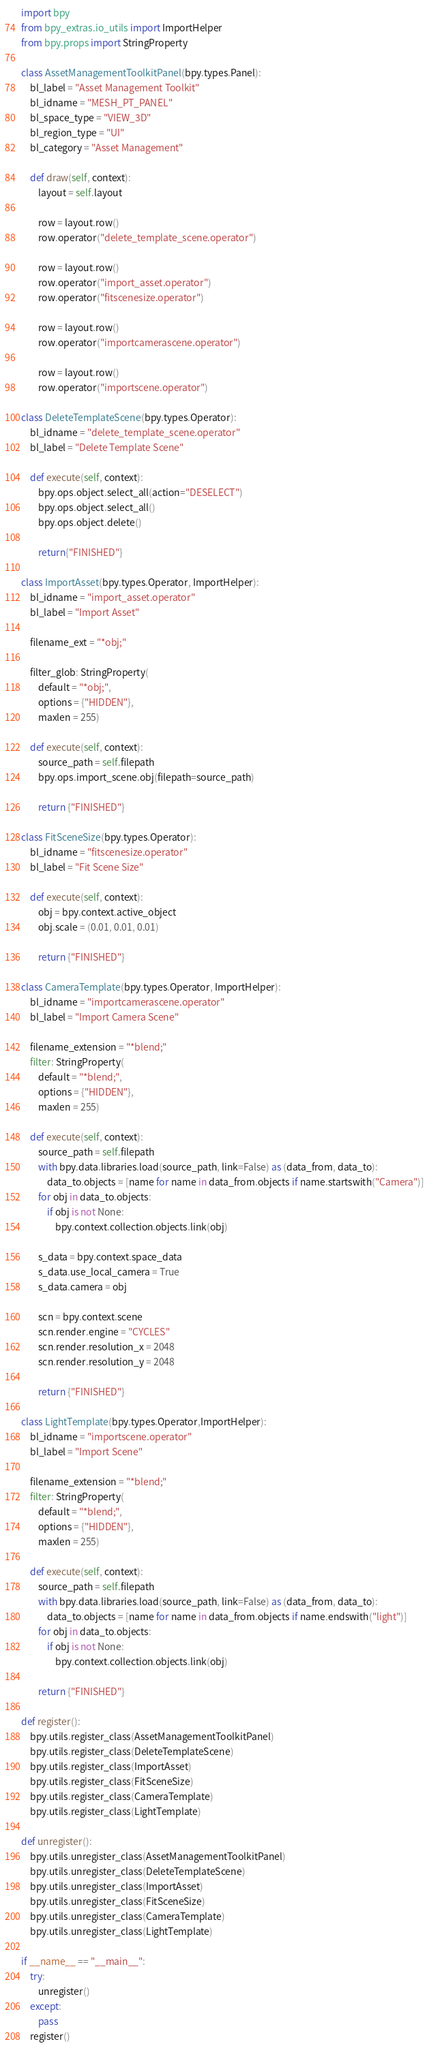Convert code to text. <code><loc_0><loc_0><loc_500><loc_500><_Python_>import bpy
from bpy_extras.io_utils import ImportHelper
from bpy.props import StringProperty

class AssetManagementToolkitPanel(bpy.types.Panel):
    bl_label = "Asset Management Toolkit"
    bl_idname = "MESH_PT_PANEL"
    bl_space_type = "VIEW_3D"
    bl_region_type = "UI"
    bl_category = "Asset Management"

    def draw(self, context):
        layout = self.layout
        
        row = layout.row()
        row.operator("delete_template_scene.operator")
        
        row = layout.row()
        row.operator("import_asset.operator")
        row.operator("fitscenesize.operator")

        row = layout.row()
        row.operator("importcamerascene.operator")
        
        row = layout.row()
        row.operator("importscene.operator")

class DeleteTemplateScene(bpy.types.Operator):
    bl_idname = "delete_template_scene.operator"
    bl_label = "Delete Template Scene"

    def execute(self, context):
        bpy.ops.object.select_all(action="DESELECT")
        bpy.ops.object.select_all()
        bpy.ops.object.delete()

        return{"FINISHED"}

class ImportAsset(bpy.types.Operator, ImportHelper):
    bl_idname = "import_asset.operator"
    bl_label = "Import Asset"

    filename_ext = "*obj;"

    filter_glob: StringProperty(
        default = "*obj;",
        options = {"HIDDEN"},
        maxlen = 255)

    def execute(self, context):
        source_path = self.filepath
        bpy.ops.import_scene.obj(filepath=source_path)

        return {"FINISHED"}
    
class FitSceneSize(bpy.types.Operator):
    bl_idname = "fitscenesize.operator"
    bl_label = "Fit Scene Size"
    
    def execute(self, context):
        obj = bpy.context.active_object
        obj.scale = (0.01, 0.01, 0.01)
        
        return {"FINISHED"}    

class CameraTemplate(bpy.types.Operator, ImportHelper):
    bl_idname = "importcamerascene.operator"
    bl_label = "Import Camera Scene"

    filename_extension = "*blend;"
    filter: StringProperty(
        default = "*blend;",
        options = {"HIDDEN"},
        maxlen = 255)
    
    def execute(self, context):
        source_path = self.filepath
        with bpy.data.libraries.load(source_path, link=False) as (data_from, data_to):
            data_to.objects = [name for name in data_from.objects if name.startswith("Camera")]
        for obj in data_to.objects:
            if obj is not None:
                bpy.context.collection.objects.link(obj)
                
        s_data = bpy.context.space_data
        s_data.use_local_camera = True
        s_data.camera = obj
        
        scn = bpy.context.scene
        scn.render.engine = "CYCLES"   
        scn.render.resolution_x = 2048
        scn.render.resolution_y = 2048
        
        return {"FINISHED"}

class LightTemplate(bpy.types.Operator,ImportHelper):
    bl_idname = "importscene.operator"
    bl_label = "Import Scene"

    filename_extension = "*blend;"
    filter: StringProperty(
        default = "*blend;",
        options = {"HIDDEN"},
        maxlen = 255)
    
    def execute(self, context):
        source_path = self.filepath
        with bpy.data.libraries.load(source_path, link=False) as (data_from, data_to):
            data_to.objects = [name for name in data_from.objects if name.endswith("light")]
        for obj in data_to.objects:
            if obj is not None:
                bpy.context.collection.objects.link(obj)
                   
        return {"FINISHED"}
    
def register():
    bpy.utils.register_class(AssetManagementToolkitPanel)
    bpy.utils.register_class(DeleteTemplateScene)
    bpy.utils.register_class(ImportAsset)
    bpy.utils.register_class(FitSceneSize)
    bpy.utils.register_class(CameraTemplate)
    bpy.utils.register_class(LightTemplate)

def unregister():
    bpy.utils.unregister_class(AssetManagementToolkitPanel)
    bpy.utils.unregister_class(DeleteTemplateScene)
    bpy.utils.unregister_class(ImportAsset)
    bpy.utils.unregister_class(FitSceneSize)
    bpy.utils.unregister_class(CameraTemplate)
    bpy.utils.unregister_class(LightTemplate)

if __name__ == "__main__":
    try:
        unregister()
    except:
        pass
    register()</code> 